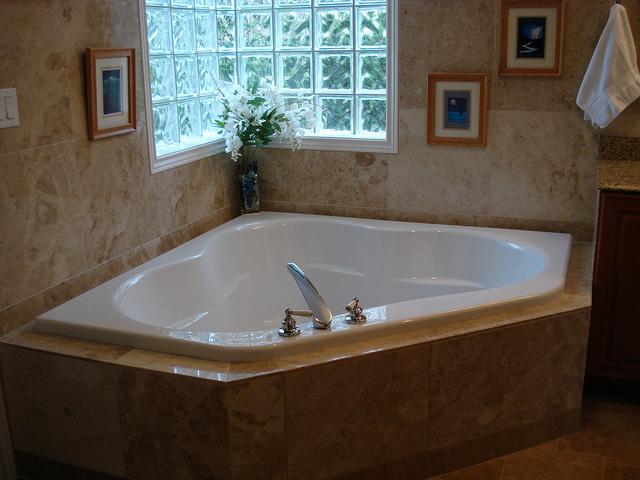Is there a mirror in this photo?
Quick response, please. No. What type of glass is used for the window?
Quick response, please. Frosted. How many pictures are on the wall?
Give a very brief answer. 3. 